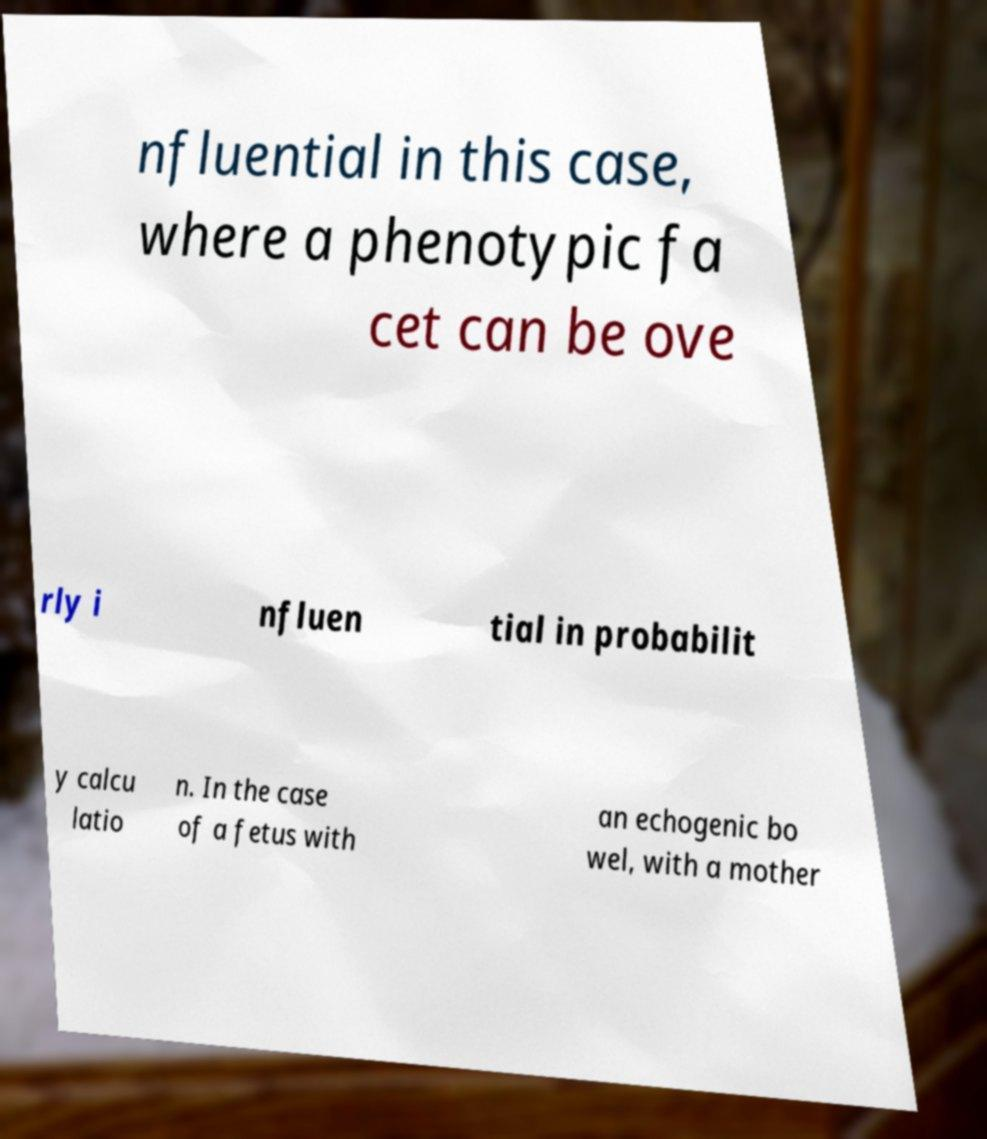Could you assist in decoding the text presented in this image and type it out clearly? nfluential in this case, where a phenotypic fa cet can be ove rly i nfluen tial in probabilit y calcu latio n. In the case of a fetus with an echogenic bo wel, with a mother 